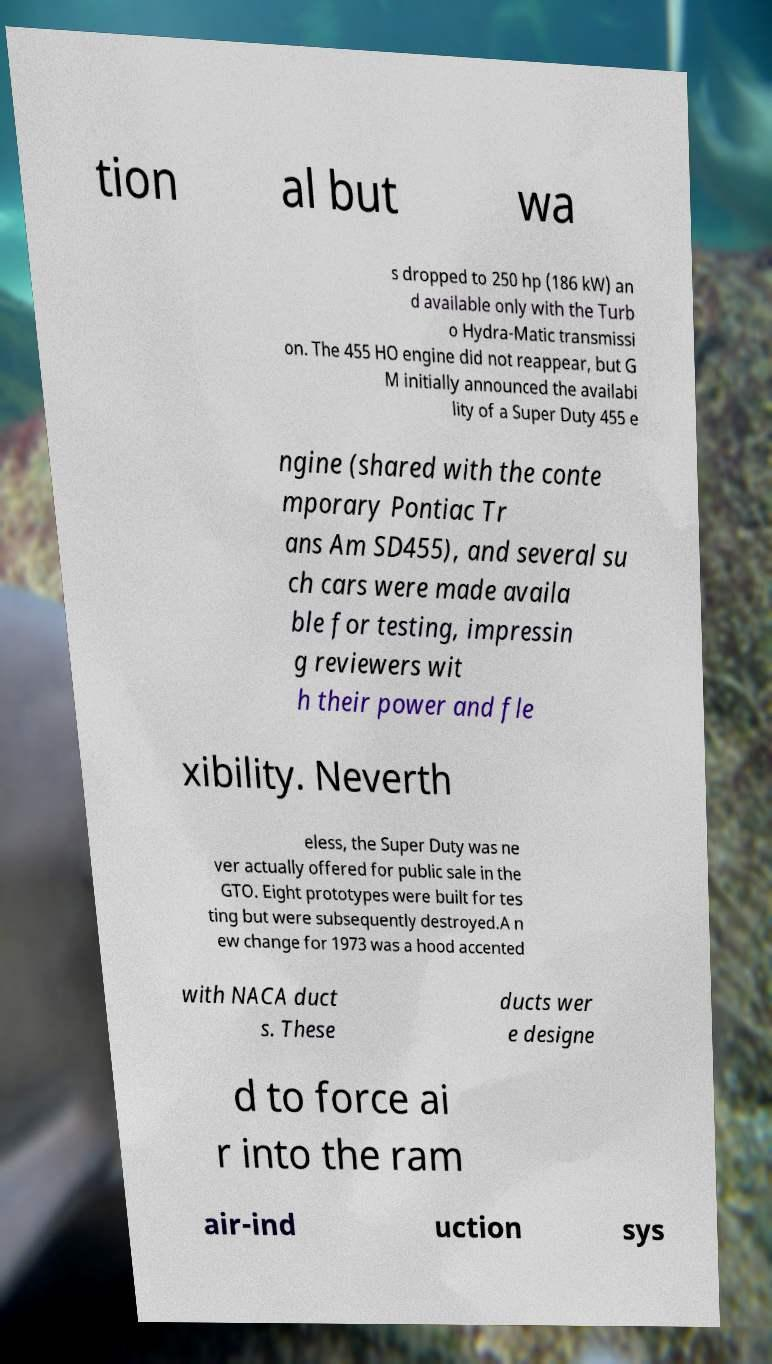I need the written content from this picture converted into text. Can you do that? tion al but wa s dropped to 250 hp (186 kW) an d available only with the Turb o Hydra-Matic transmissi on. The 455 HO engine did not reappear, but G M initially announced the availabi lity of a Super Duty 455 e ngine (shared with the conte mporary Pontiac Tr ans Am SD455), and several su ch cars were made availa ble for testing, impressin g reviewers wit h their power and fle xibility. Neverth eless, the Super Duty was ne ver actually offered for public sale in the GTO. Eight prototypes were built for tes ting but were subsequently destroyed.A n ew change for 1973 was a hood accented with NACA duct s. These ducts wer e designe d to force ai r into the ram air-ind uction sys 